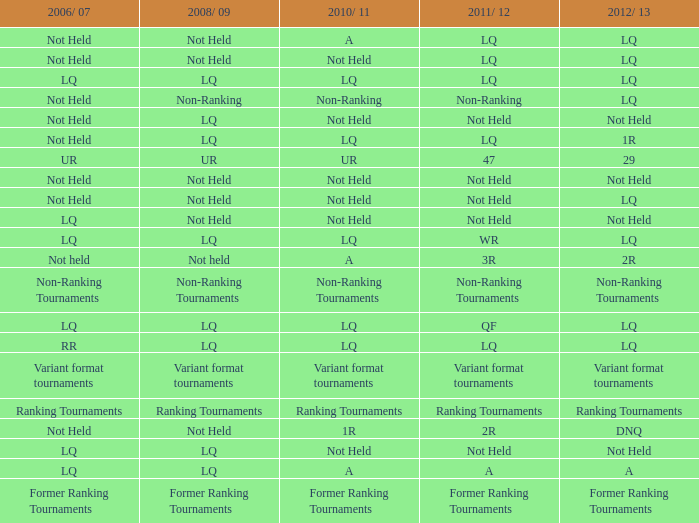What is 2006/07, when 2008/09 is LQ, and when 2010/11 is Not Held? LQ, Not Held. 